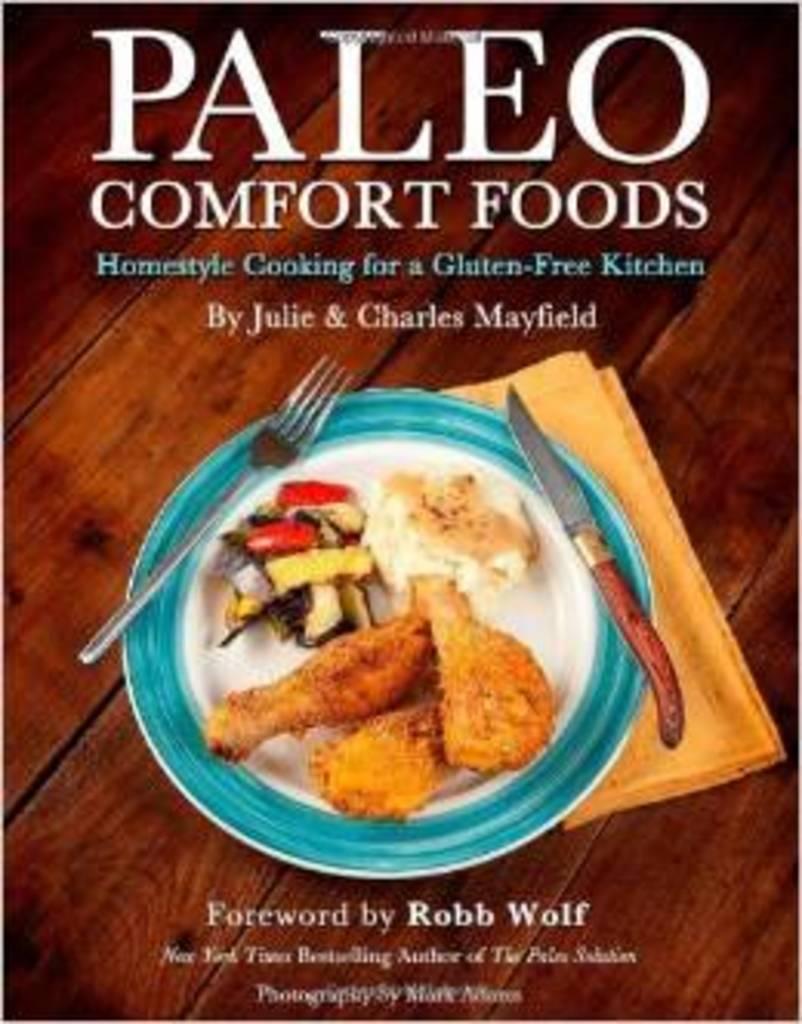Could you give a brief overview of what you see in this image? In this picture, we can see a table. On that table, we can see some text and a plate with some food, knife, fork, we can also see a cloth on the table. 